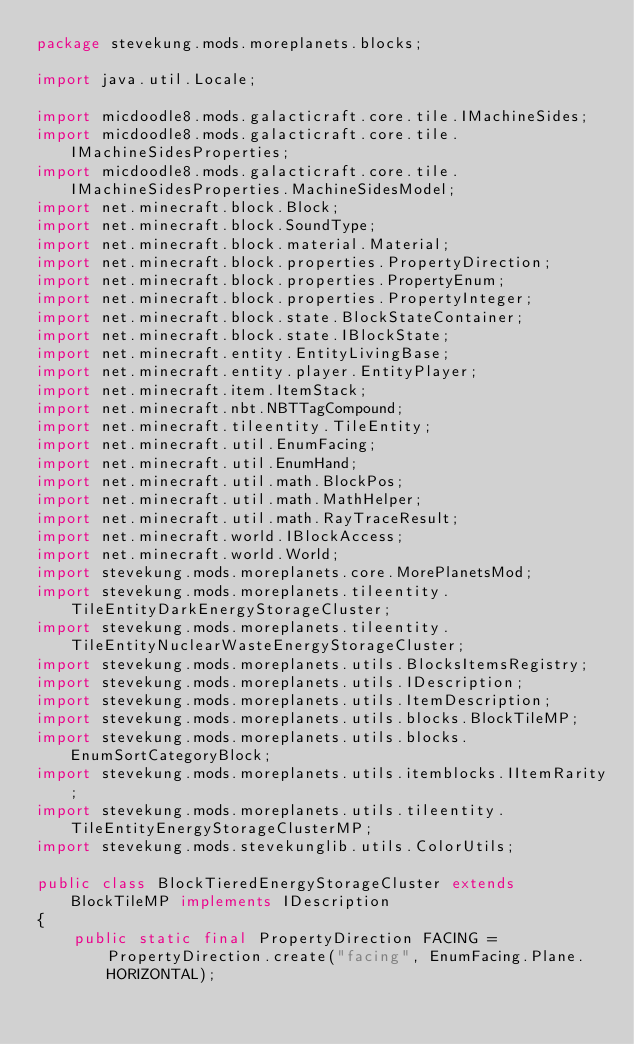Convert code to text. <code><loc_0><loc_0><loc_500><loc_500><_Java_>package stevekung.mods.moreplanets.blocks;

import java.util.Locale;

import micdoodle8.mods.galacticraft.core.tile.IMachineSides;
import micdoodle8.mods.galacticraft.core.tile.IMachineSidesProperties;
import micdoodle8.mods.galacticraft.core.tile.IMachineSidesProperties.MachineSidesModel;
import net.minecraft.block.Block;
import net.minecraft.block.SoundType;
import net.minecraft.block.material.Material;
import net.minecraft.block.properties.PropertyDirection;
import net.minecraft.block.properties.PropertyEnum;
import net.minecraft.block.properties.PropertyInteger;
import net.minecraft.block.state.BlockStateContainer;
import net.minecraft.block.state.IBlockState;
import net.minecraft.entity.EntityLivingBase;
import net.minecraft.entity.player.EntityPlayer;
import net.minecraft.item.ItemStack;
import net.minecraft.nbt.NBTTagCompound;
import net.minecraft.tileentity.TileEntity;
import net.minecraft.util.EnumFacing;
import net.minecraft.util.EnumHand;
import net.minecraft.util.math.BlockPos;
import net.minecraft.util.math.MathHelper;
import net.minecraft.util.math.RayTraceResult;
import net.minecraft.world.IBlockAccess;
import net.minecraft.world.World;
import stevekung.mods.moreplanets.core.MorePlanetsMod;
import stevekung.mods.moreplanets.tileentity.TileEntityDarkEnergyStorageCluster;
import stevekung.mods.moreplanets.tileentity.TileEntityNuclearWasteEnergyStorageCluster;
import stevekung.mods.moreplanets.utils.BlocksItemsRegistry;
import stevekung.mods.moreplanets.utils.IDescription;
import stevekung.mods.moreplanets.utils.ItemDescription;
import stevekung.mods.moreplanets.utils.blocks.BlockTileMP;
import stevekung.mods.moreplanets.utils.blocks.EnumSortCategoryBlock;
import stevekung.mods.moreplanets.utils.itemblocks.IItemRarity;
import stevekung.mods.moreplanets.utils.tileentity.TileEntityEnergyStorageClusterMP;
import stevekung.mods.stevekunglib.utils.ColorUtils;

public class BlockTieredEnergyStorageCluster extends BlockTileMP implements IDescription
{
    public static final PropertyDirection FACING = PropertyDirection.create("facing", EnumFacing.Plane.HORIZONTAL);</code> 